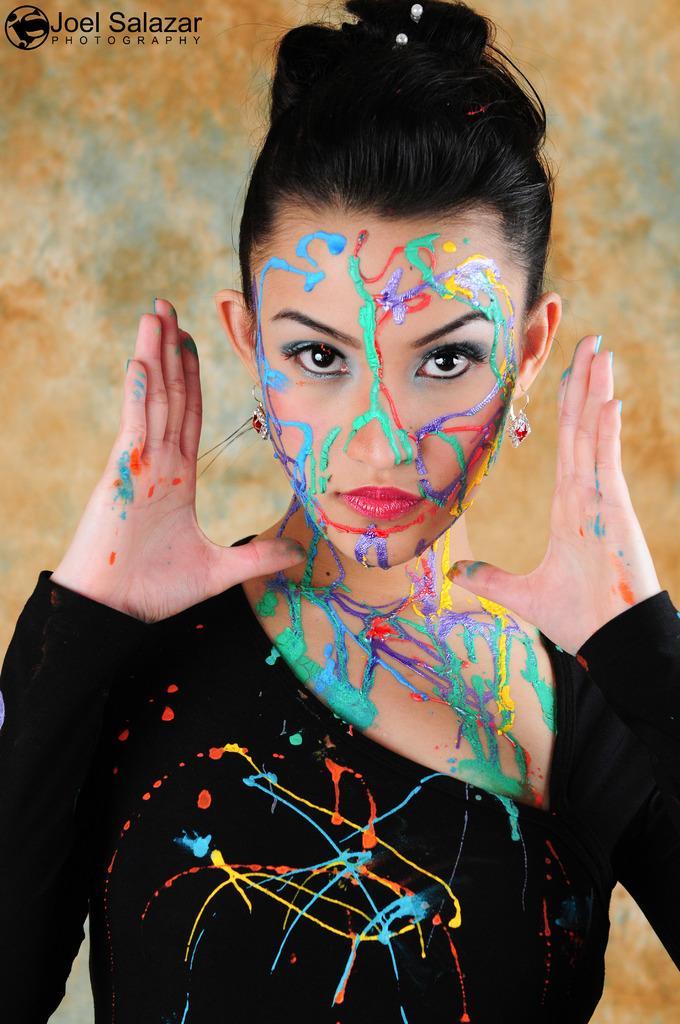In one or two sentences, can you explain what this image depicts? This image is taken indoors. In the middle of the image a woman is standing. In the background there is a wall. 